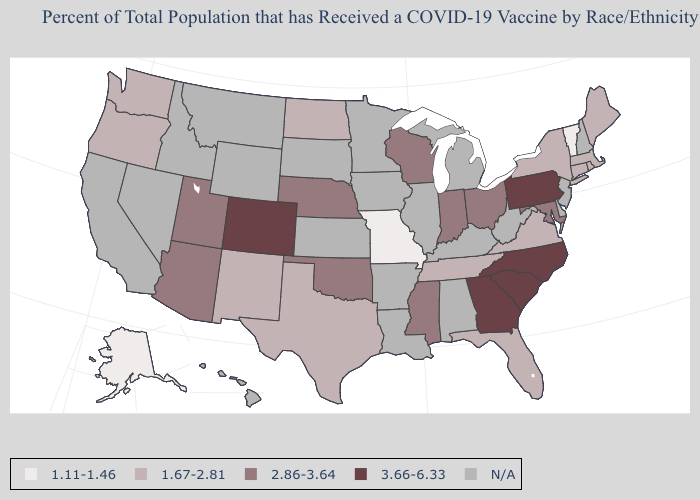Name the states that have a value in the range 1.67-2.81?
Answer briefly. Connecticut, Florida, Maine, Massachusetts, New Mexico, New York, North Dakota, Oregon, Rhode Island, Tennessee, Texas, Virginia, Washington. Name the states that have a value in the range N/A?
Be succinct. Alabama, Arkansas, California, Delaware, Hawaii, Idaho, Illinois, Iowa, Kansas, Kentucky, Louisiana, Michigan, Minnesota, Montana, Nevada, New Hampshire, New Jersey, South Dakota, West Virginia, Wyoming. What is the lowest value in the MidWest?
Answer briefly. 1.11-1.46. What is the value of Iowa?
Concise answer only. N/A. Which states have the highest value in the USA?
Short answer required. Colorado, Georgia, North Carolina, Pennsylvania, South Carolina. Name the states that have a value in the range 2.86-3.64?
Write a very short answer. Arizona, Indiana, Maryland, Mississippi, Nebraska, Ohio, Oklahoma, Utah, Wisconsin. What is the value of Arkansas?
Write a very short answer. N/A. Among the states that border Wyoming , does Colorado have the highest value?
Answer briefly. Yes. Name the states that have a value in the range 2.86-3.64?
Give a very brief answer. Arizona, Indiana, Maryland, Mississippi, Nebraska, Ohio, Oklahoma, Utah, Wisconsin. What is the value of Michigan?
Concise answer only. N/A. Does Wisconsin have the lowest value in the MidWest?
Keep it brief. No. Which states have the lowest value in the USA?
Give a very brief answer. Alaska, Missouri, Vermont. Name the states that have a value in the range 2.86-3.64?
Give a very brief answer. Arizona, Indiana, Maryland, Mississippi, Nebraska, Ohio, Oklahoma, Utah, Wisconsin. Among the states that border Wyoming , does Utah have the lowest value?
Concise answer only. Yes. Is the legend a continuous bar?
Be succinct. No. 